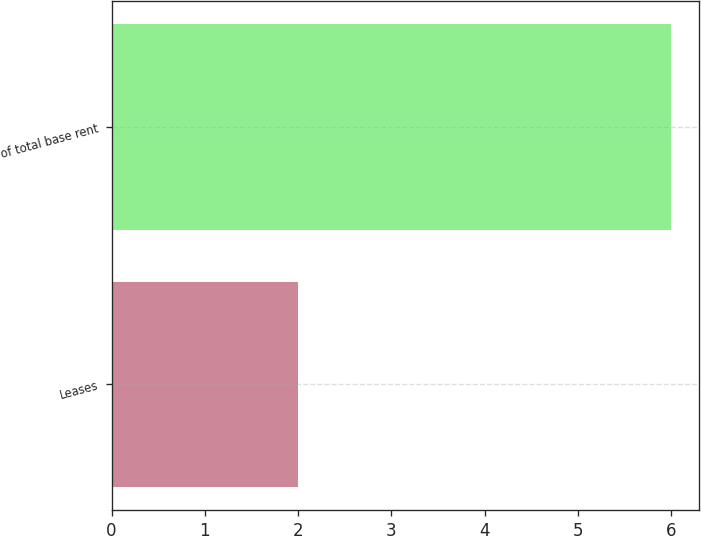<chart> <loc_0><loc_0><loc_500><loc_500><bar_chart><fcel>Leases<fcel>of total base rent<nl><fcel>2<fcel>6<nl></chart> 